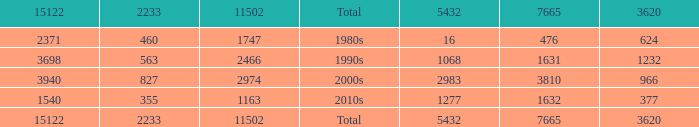What is the highest 3620 value with a 5432 of 5432 and a 15122 greater than 15122? None. 